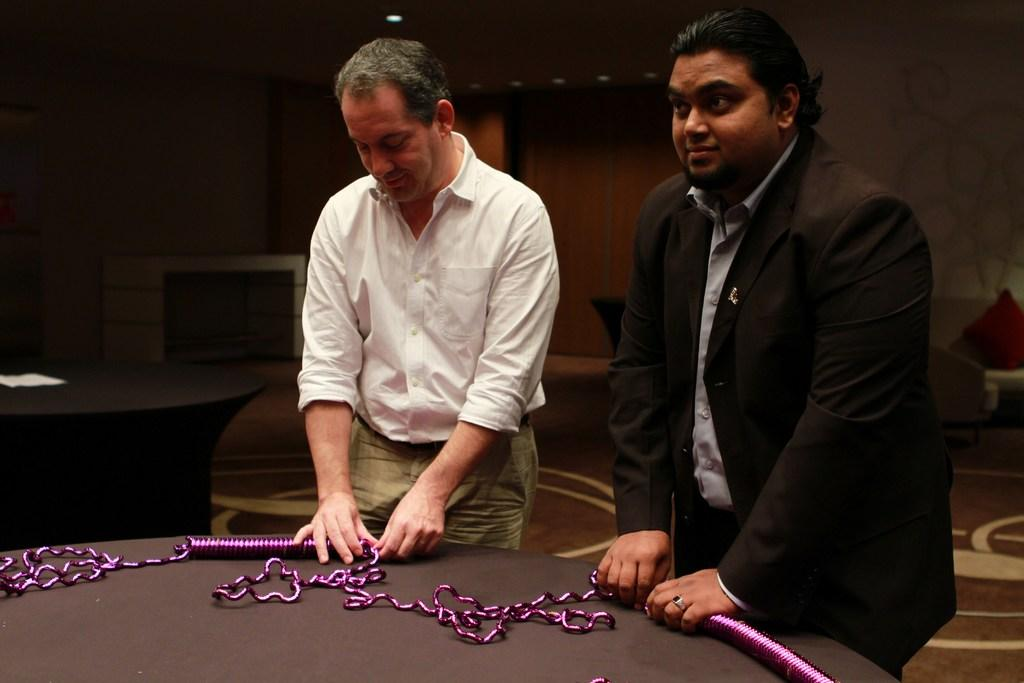How many people are in the image? There are two persons in the image. What are the two persons doing in the image? The two persons are standing and doing something on a table. What type of gun is being used by one of the persons in the image? There is no gun present in the image; the two persons are not depicted with any weapons. 